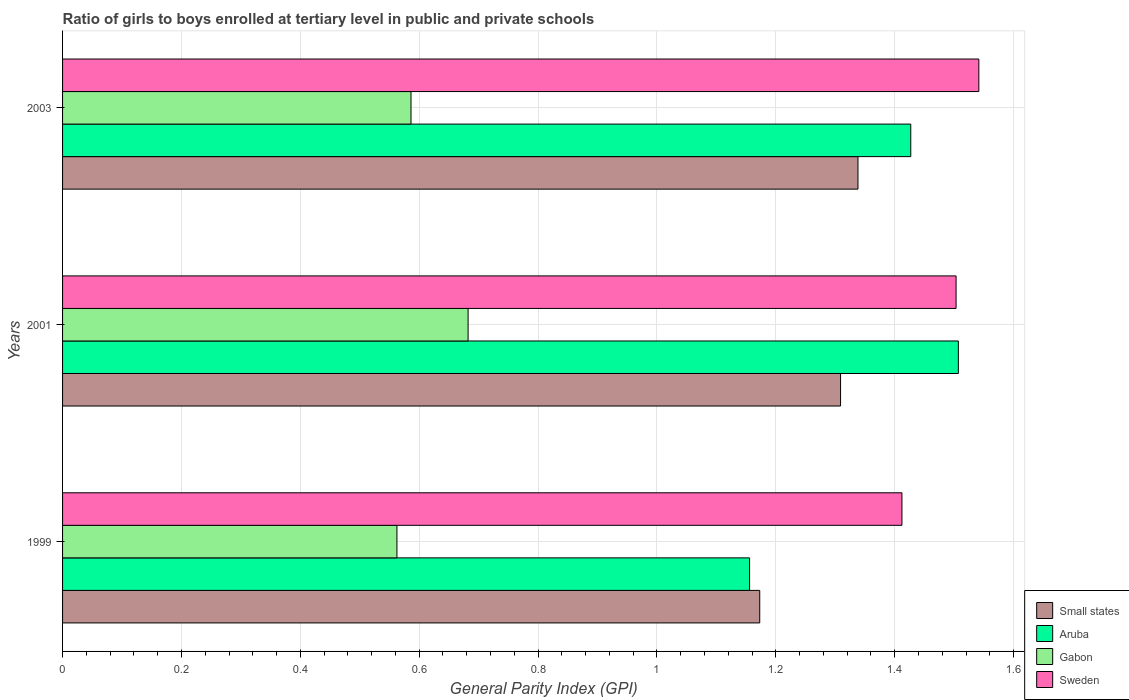How many groups of bars are there?
Your answer should be compact. 3. How many bars are there on the 1st tick from the top?
Your answer should be compact. 4. What is the general parity index in Aruba in 1999?
Your response must be concise. 1.16. Across all years, what is the maximum general parity index in Aruba?
Provide a short and direct response. 1.51. Across all years, what is the minimum general parity index in Gabon?
Offer a terse response. 0.56. In which year was the general parity index in Gabon maximum?
Offer a terse response. 2001. In which year was the general parity index in Sweden minimum?
Offer a terse response. 1999. What is the total general parity index in Small states in the graph?
Offer a terse response. 3.82. What is the difference between the general parity index in Aruba in 2001 and that in 2003?
Your answer should be very brief. 0.08. What is the difference between the general parity index in Aruba in 2001 and the general parity index in Small states in 1999?
Provide a short and direct response. 0.33. What is the average general parity index in Gabon per year?
Your response must be concise. 0.61. In the year 2001, what is the difference between the general parity index in Small states and general parity index in Gabon?
Keep it short and to the point. 0.63. In how many years, is the general parity index in Sweden greater than 0.04 ?
Ensure brevity in your answer.  3. What is the ratio of the general parity index in Small states in 2001 to that in 2003?
Offer a very short reply. 0.98. Is the general parity index in Aruba in 1999 less than that in 2001?
Provide a succinct answer. Yes. What is the difference between the highest and the second highest general parity index in Small states?
Provide a succinct answer. 0.03. What is the difference between the highest and the lowest general parity index in Gabon?
Ensure brevity in your answer.  0.12. In how many years, is the general parity index in Aruba greater than the average general parity index in Aruba taken over all years?
Ensure brevity in your answer.  2. Is the sum of the general parity index in Small states in 1999 and 2001 greater than the maximum general parity index in Sweden across all years?
Keep it short and to the point. Yes. What does the 2nd bar from the top in 2003 represents?
Your answer should be compact. Gabon. Is it the case that in every year, the sum of the general parity index in Aruba and general parity index in Gabon is greater than the general parity index in Sweden?
Keep it short and to the point. Yes. How many bars are there?
Offer a terse response. 12. How many years are there in the graph?
Give a very brief answer. 3. What is the difference between two consecutive major ticks on the X-axis?
Your answer should be very brief. 0.2. Are the values on the major ticks of X-axis written in scientific E-notation?
Offer a terse response. No. Does the graph contain any zero values?
Give a very brief answer. No. Does the graph contain grids?
Ensure brevity in your answer.  Yes. Where does the legend appear in the graph?
Provide a short and direct response. Bottom right. What is the title of the graph?
Your answer should be very brief. Ratio of girls to boys enrolled at tertiary level in public and private schools. What is the label or title of the X-axis?
Offer a terse response. General Parity Index (GPI). What is the label or title of the Y-axis?
Your response must be concise. Years. What is the General Parity Index (GPI) in Small states in 1999?
Your answer should be very brief. 1.17. What is the General Parity Index (GPI) of Aruba in 1999?
Your answer should be compact. 1.16. What is the General Parity Index (GPI) in Gabon in 1999?
Provide a short and direct response. 0.56. What is the General Parity Index (GPI) in Sweden in 1999?
Offer a terse response. 1.41. What is the General Parity Index (GPI) in Small states in 2001?
Provide a short and direct response. 1.31. What is the General Parity Index (GPI) in Aruba in 2001?
Make the answer very short. 1.51. What is the General Parity Index (GPI) in Gabon in 2001?
Make the answer very short. 0.68. What is the General Parity Index (GPI) of Sweden in 2001?
Offer a terse response. 1.5. What is the General Parity Index (GPI) in Small states in 2003?
Keep it short and to the point. 1.34. What is the General Parity Index (GPI) of Aruba in 2003?
Ensure brevity in your answer.  1.43. What is the General Parity Index (GPI) in Gabon in 2003?
Give a very brief answer. 0.59. What is the General Parity Index (GPI) in Sweden in 2003?
Your response must be concise. 1.54. Across all years, what is the maximum General Parity Index (GPI) of Small states?
Your response must be concise. 1.34. Across all years, what is the maximum General Parity Index (GPI) in Aruba?
Make the answer very short. 1.51. Across all years, what is the maximum General Parity Index (GPI) of Gabon?
Your answer should be compact. 0.68. Across all years, what is the maximum General Parity Index (GPI) in Sweden?
Ensure brevity in your answer.  1.54. Across all years, what is the minimum General Parity Index (GPI) in Small states?
Provide a succinct answer. 1.17. Across all years, what is the minimum General Parity Index (GPI) in Aruba?
Provide a succinct answer. 1.16. Across all years, what is the minimum General Parity Index (GPI) in Gabon?
Provide a succinct answer. 0.56. Across all years, what is the minimum General Parity Index (GPI) in Sweden?
Your response must be concise. 1.41. What is the total General Parity Index (GPI) in Small states in the graph?
Keep it short and to the point. 3.82. What is the total General Parity Index (GPI) of Aruba in the graph?
Offer a very short reply. 4.09. What is the total General Parity Index (GPI) of Gabon in the graph?
Ensure brevity in your answer.  1.83. What is the total General Parity Index (GPI) of Sweden in the graph?
Offer a very short reply. 4.46. What is the difference between the General Parity Index (GPI) in Small states in 1999 and that in 2001?
Offer a very short reply. -0.14. What is the difference between the General Parity Index (GPI) in Aruba in 1999 and that in 2001?
Give a very brief answer. -0.35. What is the difference between the General Parity Index (GPI) in Gabon in 1999 and that in 2001?
Make the answer very short. -0.12. What is the difference between the General Parity Index (GPI) of Sweden in 1999 and that in 2001?
Make the answer very short. -0.09. What is the difference between the General Parity Index (GPI) in Small states in 1999 and that in 2003?
Give a very brief answer. -0.17. What is the difference between the General Parity Index (GPI) in Aruba in 1999 and that in 2003?
Offer a terse response. -0.27. What is the difference between the General Parity Index (GPI) of Gabon in 1999 and that in 2003?
Provide a short and direct response. -0.02. What is the difference between the General Parity Index (GPI) in Sweden in 1999 and that in 2003?
Offer a terse response. -0.13. What is the difference between the General Parity Index (GPI) in Small states in 2001 and that in 2003?
Provide a short and direct response. -0.03. What is the difference between the General Parity Index (GPI) in Aruba in 2001 and that in 2003?
Give a very brief answer. 0.08. What is the difference between the General Parity Index (GPI) in Gabon in 2001 and that in 2003?
Offer a terse response. 0.1. What is the difference between the General Parity Index (GPI) of Sweden in 2001 and that in 2003?
Your response must be concise. -0.04. What is the difference between the General Parity Index (GPI) in Small states in 1999 and the General Parity Index (GPI) in Aruba in 2001?
Your response must be concise. -0.33. What is the difference between the General Parity Index (GPI) of Small states in 1999 and the General Parity Index (GPI) of Gabon in 2001?
Your response must be concise. 0.49. What is the difference between the General Parity Index (GPI) in Small states in 1999 and the General Parity Index (GPI) in Sweden in 2001?
Provide a short and direct response. -0.33. What is the difference between the General Parity Index (GPI) of Aruba in 1999 and the General Parity Index (GPI) of Gabon in 2001?
Ensure brevity in your answer.  0.47. What is the difference between the General Parity Index (GPI) of Aruba in 1999 and the General Parity Index (GPI) of Sweden in 2001?
Provide a succinct answer. -0.35. What is the difference between the General Parity Index (GPI) of Gabon in 1999 and the General Parity Index (GPI) of Sweden in 2001?
Offer a terse response. -0.94. What is the difference between the General Parity Index (GPI) of Small states in 1999 and the General Parity Index (GPI) of Aruba in 2003?
Your response must be concise. -0.25. What is the difference between the General Parity Index (GPI) in Small states in 1999 and the General Parity Index (GPI) in Gabon in 2003?
Give a very brief answer. 0.59. What is the difference between the General Parity Index (GPI) of Small states in 1999 and the General Parity Index (GPI) of Sweden in 2003?
Make the answer very short. -0.37. What is the difference between the General Parity Index (GPI) in Aruba in 1999 and the General Parity Index (GPI) in Gabon in 2003?
Your answer should be compact. 0.57. What is the difference between the General Parity Index (GPI) of Aruba in 1999 and the General Parity Index (GPI) of Sweden in 2003?
Ensure brevity in your answer.  -0.39. What is the difference between the General Parity Index (GPI) of Gabon in 1999 and the General Parity Index (GPI) of Sweden in 2003?
Offer a very short reply. -0.98. What is the difference between the General Parity Index (GPI) of Small states in 2001 and the General Parity Index (GPI) of Aruba in 2003?
Your answer should be compact. -0.12. What is the difference between the General Parity Index (GPI) in Small states in 2001 and the General Parity Index (GPI) in Gabon in 2003?
Your response must be concise. 0.72. What is the difference between the General Parity Index (GPI) in Small states in 2001 and the General Parity Index (GPI) in Sweden in 2003?
Make the answer very short. -0.23. What is the difference between the General Parity Index (GPI) of Aruba in 2001 and the General Parity Index (GPI) of Gabon in 2003?
Ensure brevity in your answer.  0.92. What is the difference between the General Parity Index (GPI) in Aruba in 2001 and the General Parity Index (GPI) in Sweden in 2003?
Keep it short and to the point. -0.03. What is the difference between the General Parity Index (GPI) of Gabon in 2001 and the General Parity Index (GPI) of Sweden in 2003?
Make the answer very short. -0.86. What is the average General Parity Index (GPI) in Small states per year?
Your response must be concise. 1.27. What is the average General Parity Index (GPI) of Aruba per year?
Ensure brevity in your answer.  1.36. What is the average General Parity Index (GPI) of Gabon per year?
Offer a terse response. 0.61. What is the average General Parity Index (GPI) of Sweden per year?
Keep it short and to the point. 1.49. In the year 1999, what is the difference between the General Parity Index (GPI) of Small states and General Parity Index (GPI) of Aruba?
Your answer should be compact. 0.02. In the year 1999, what is the difference between the General Parity Index (GPI) in Small states and General Parity Index (GPI) in Gabon?
Your answer should be very brief. 0.61. In the year 1999, what is the difference between the General Parity Index (GPI) of Small states and General Parity Index (GPI) of Sweden?
Provide a succinct answer. -0.24. In the year 1999, what is the difference between the General Parity Index (GPI) in Aruba and General Parity Index (GPI) in Gabon?
Provide a short and direct response. 0.59. In the year 1999, what is the difference between the General Parity Index (GPI) in Aruba and General Parity Index (GPI) in Sweden?
Make the answer very short. -0.26. In the year 1999, what is the difference between the General Parity Index (GPI) of Gabon and General Parity Index (GPI) of Sweden?
Provide a succinct answer. -0.85. In the year 2001, what is the difference between the General Parity Index (GPI) of Small states and General Parity Index (GPI) of Aruba?
Keep it short and to the point. -0.2. In the year 2001, what is the difference between the General Parity Index (GPI) of Small states and General Parity Index (GPI) of Gabon?
Your answer should be compact. 0.63. In the year 2001, what is the difference between the General Parity Index (GPI) in Small states and General Parity Index (GPI) in Sweden?
Make the answer very short. -0.19. In the year 2001, what is the difference between the General Parity Index (GPI) in Aruba and General Parity Index (GPI) in Gabon?
Make the answer very short. 0.82. In the year 2001, what is the difference between the General Parity Index (GPI) in Aruba and General Parity Index (GPI) in Sweden?
Provide a short and direct response. 0. In the year 2001, what is the difference between the General Parity Index (GPI) of Gabon and General Parity Index (GPI) of Sweden?
Make the answer very short. -0.82. In the year 2003, what is the difference between the General Parity Index (GPI) in Small states and General Parity Index (GPI) in Aruba?
Offer a terse response. -0.09. In the year 2003, what is the difference between the General Parity Index (GPI) of Small states and General Parity Index (GPI) of Gabon?
Make the answer very short. 0.75. In the year 2003, what is the difference between the General Parity Index (GPI) of Small states and General Parity Index (GPI) of Sweden?
Your response must be concise. -0.2. In the year 2003, what is the difference between the General Parity Index (GPI) of Aruba and General Parity Index (GPI) of Gabon?
Provide a succinct answer. 0.84. In the year 2003, what is the difference between the General Parity Index (GPI) in Aruba and General Parity Index (GPI) in Sweden?
Provide a short and direct response. -0.11. In the year 2003, what is the difference between the General Parity Index (GPI) in Gabon and General Parity Index (GPI) in Sweden?
Your answer should be very brief. -0.96. What is the ratio of the General Parity Index (GPI) of Small states in 1999 to that in 2001?
Your answer should be compact. 0.9. What is the ratio of the General Parity Index (GPI) of Aruba in 1999 to that in 2001?
Provide a short and direct response. 0.77. What is the ratio of the General Parity Index (GPI) of Gabon in 1999 to that in 2001?
Keep it short and to the point. 0.82. What is the ratio of the General Parity Index (GPI) of Sweden in 1999 to that in 2001?
Provide a short and direct response. 0.94. What is the ratio of the General Parity Index (GPI) of Small states in 1999 to that in 2003?
Make the answer very short. 0.88. What is the ratio of the General Parity Index (GPI) of Aruba in 1999 to that in 2003?
Give a very brief answer. 0.81. What is the ratio of the General Parity Index (GPI) of Gabon in 1999 to that in 2003?
Offer a terse response. 0.96. What is the ratio of the General Parity Index (GPI) in Sweden in 1999 to that in 2003?
Your response must be concise. 0.92. What is the ratio of the General Parity Index (GPI) of Small states in 2001 to that in 2003?
Provide a succinct answer. 0.98. What is the ratio of the General Parity Index (GPI) in Aruba in 2001 to that in 2003?
Offer a terse response. 1.06. What is the ratio of the General Parity Index (GPI) of Gabon in 2001 to that in 2003?
Your response must be concise. 1.16. What is the ratio of the General Parity Index (GPI) in Sweden in 2001 to that in 2003?
Provide a succinct answer. 0.98. What is the difference between the highest and the second highest General Parity Index (GPI) of Small states?
Give a very brief answer. 0.03. What is the difference between the highest and the second highest General Parity Index (GPI) in Aruba?
Your answer should be compact. 0.08. What is the difference between the highest and the second highest General Parity Index (GPI) of Gabon?
Offer a terse response. 0.1. What is the difference between the highest and the second highest General Parity Index (GPI) of Sweden?
Ensure brevity in your answer.  0.04. What is the difference between the highest and the lowest General Parity Index (GPI) in Small states?
Offer a terse response. 0.17. What is the difference between the highest and the lowest General Parity Index (GPI) of Aruba?
Offer a terse response. 0.35. What is the difference between the highest and the lowest General Parity Index (GPI) in Gabon?
Ensure brevity in your answer.  0.12. What is the difference between the highest and the lowest General Parity Index (GPI) of Sweden?
Ensure brevity in your answer.  0.13. 